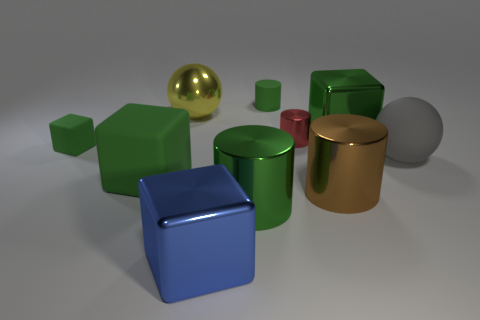How many green blocks must be subtracted to get 1 green blocks? 2 Subtract all tiny green matte cylinders. How many cylinders are left? 3 Subtract all yellow spheres. How many spheres are left? 1 Subtract all balls. How many objects are left? 8 Add 8 big blue matte cubes. How many big blue matte cubes exist? 8 Subtract 0 purple spheres. How many objects are left? 10 Subtract 4 cylinders. How many cylinders are left? 0 Subtract all green cylinders. Subtract all gray blocks. How many cylinders are left? 2 Subtract all green spheres. How many red cylinders are left? 1 Subtract all brown shiny cylinders. Subtract all big brown shiny cylinders. How many objects are left? 8 